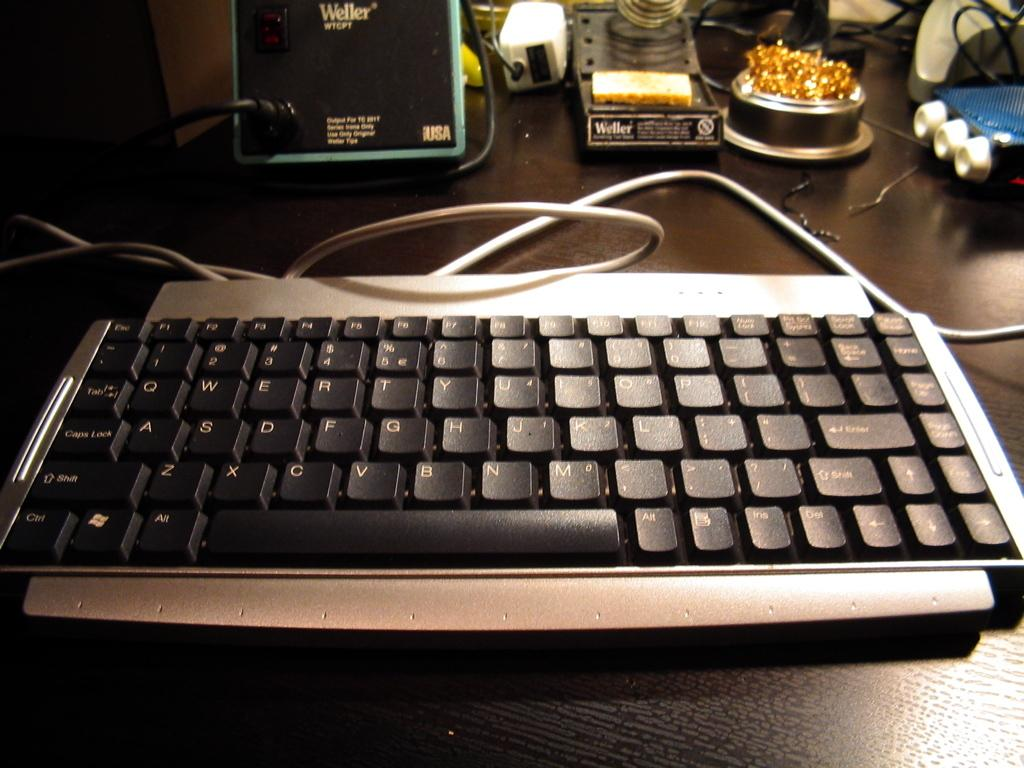Provide a one-sentence caption for the provided image. A keyboard place on a table in front of a Weller soldering iron. 